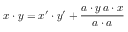<formula> <loc_0><loc_0><loc_500><loc_500>x \cdot y = x ^ { \prime } \cdot y ^ { \prime } + { \frac { a \cdot y \, a \cdot x } { a \cdot a } }</formula> 